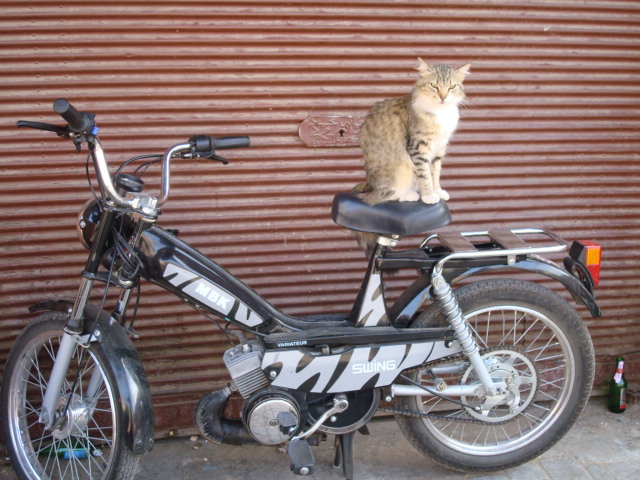<image>What is attached to the bicycle? The answer is unclear. The bicycle could have a cat, a motor, or a rack attached to it. What is attached to the bicycle? I don't know what is attached to the bicycle. It can be seen cat, motor or rack. 